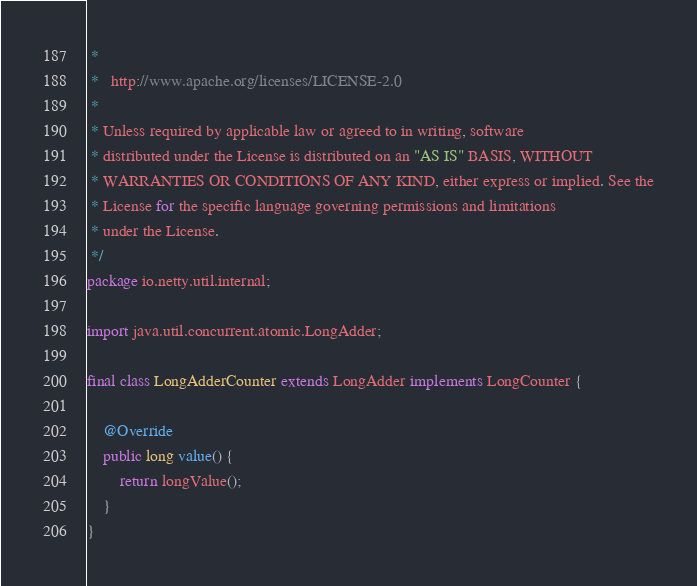Convert code to text. <code><loc_0><loc_0><loc_500><loc_500><_Java_> *
 *   http://www.apache.org/licenses/LICENSE-2.0
 *
 * Unless required by applicable law or agreed to in writing, software
 * distributed under the License is distributed on an "AS IS" BASIS, WITHOUT
 * WARRANTIES OR CONDITIONS OF ANY KIND, either express or implied. See the
 * License for the specific language governing permissions and limitations
 * under the License.
 */
package io.netty.util.internal;

import java.util.concurrent.atomic.LongAdder;

final class LongAdderCounter extends LongAdder implements LongCounter {

    @Override
    public long value() {
        return longValue();
    }
}
</code> 